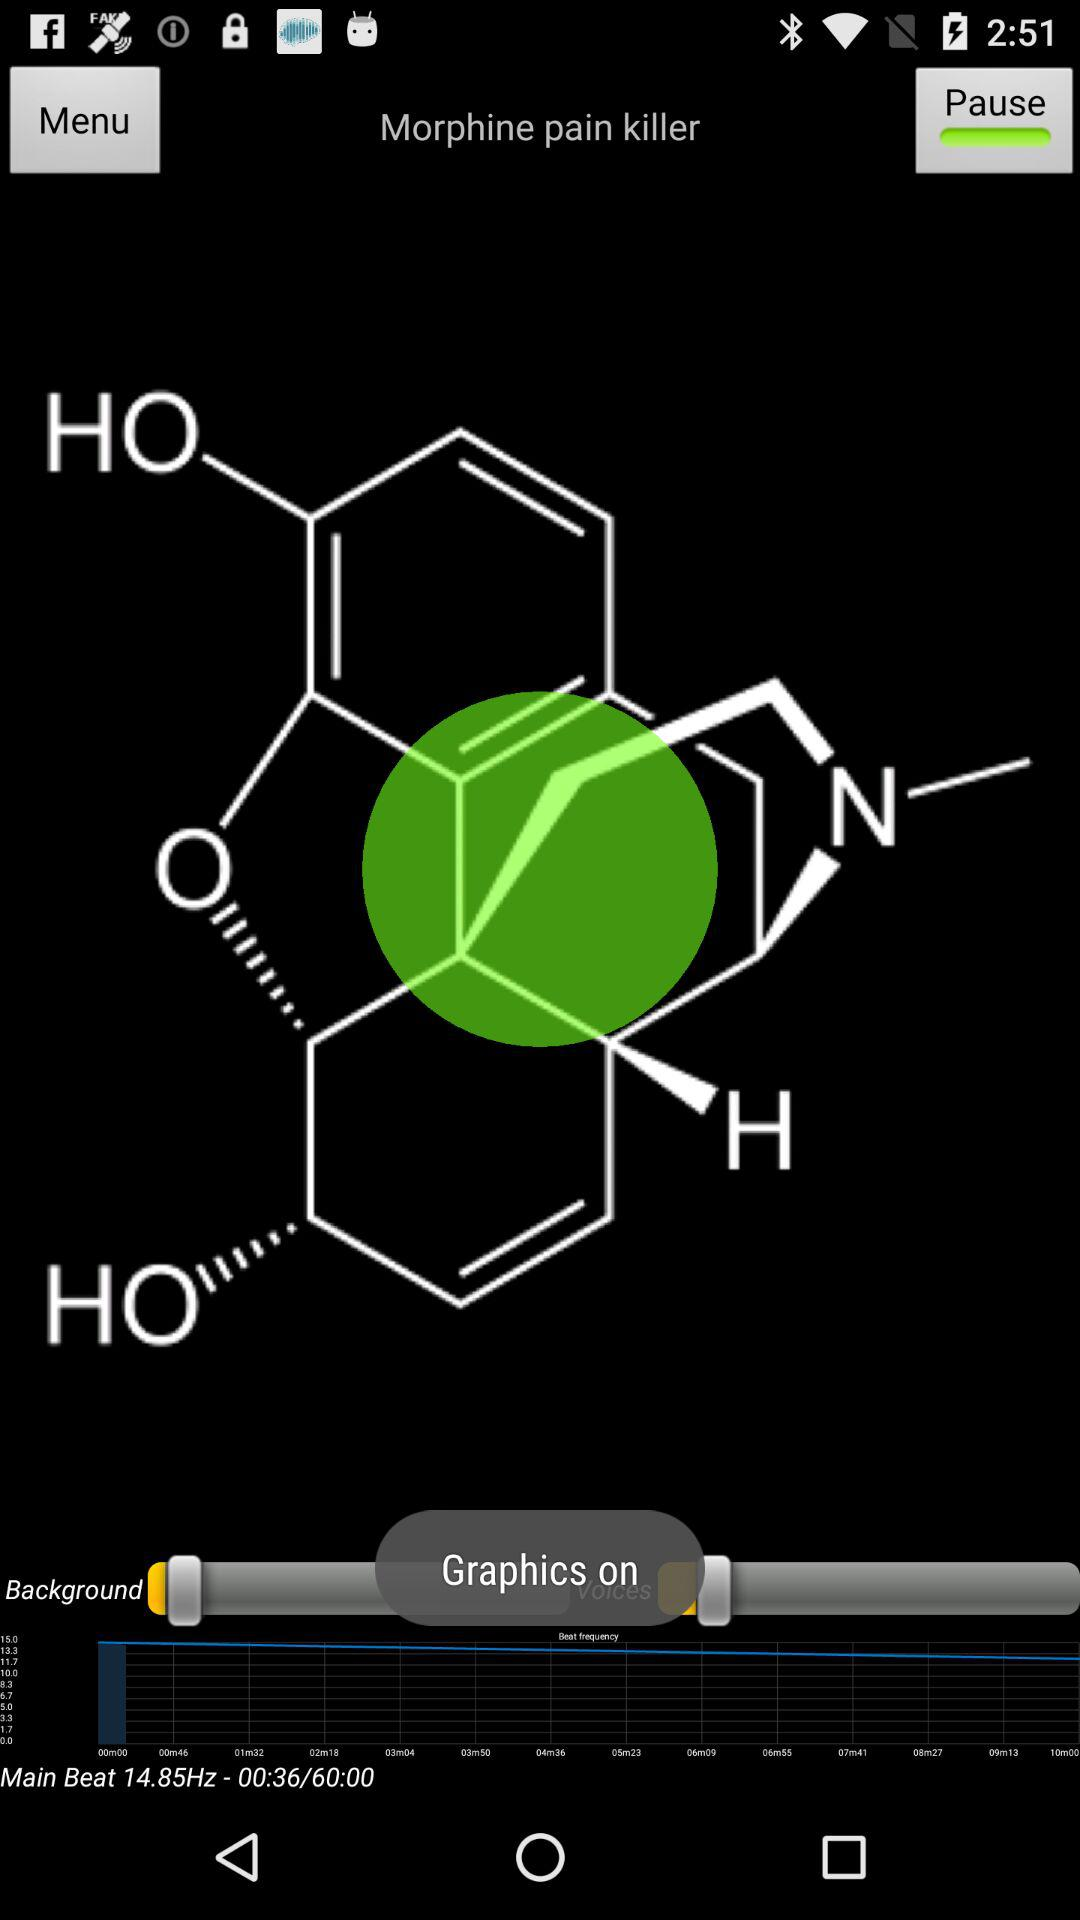Are graphics on or off?
Answer the question using a single word or phrase. Graphics are "on". 